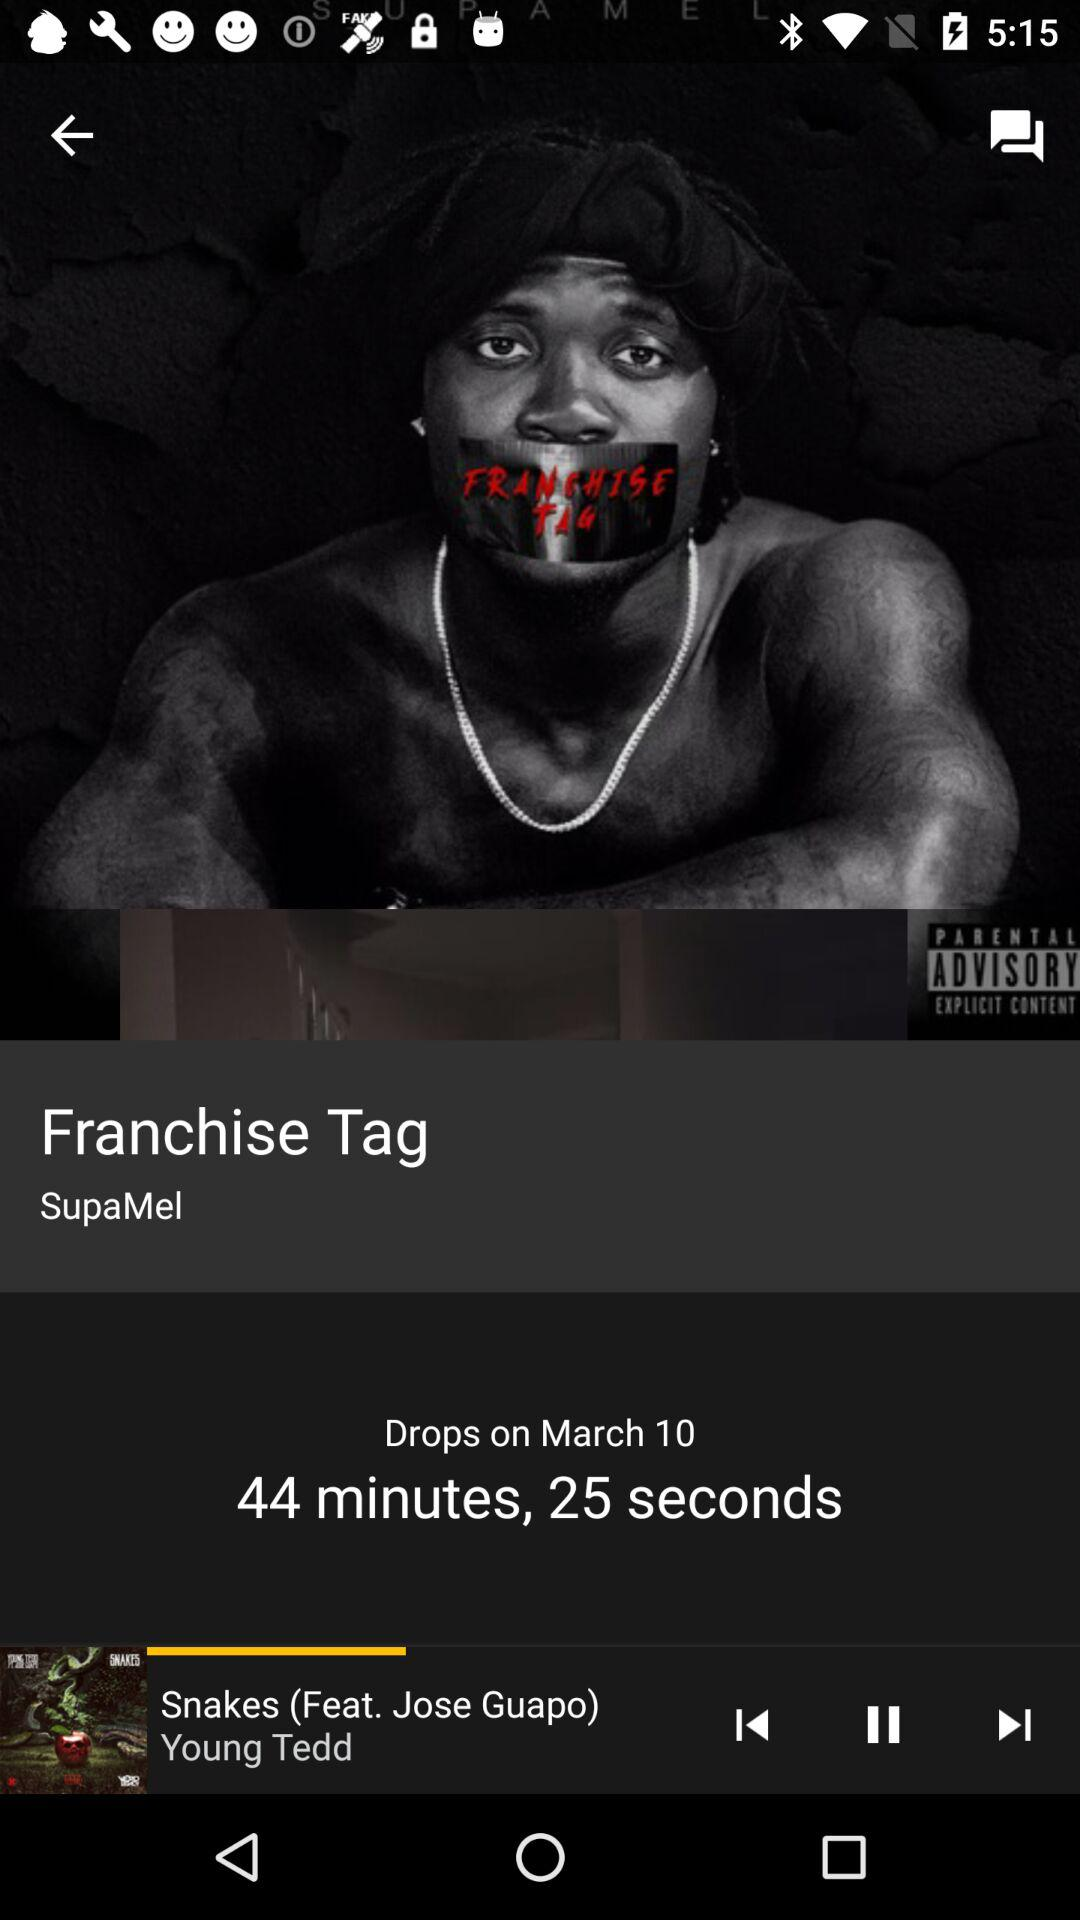What is the name of the album shown on the screen? The name of the album is "Franchise Tag". 